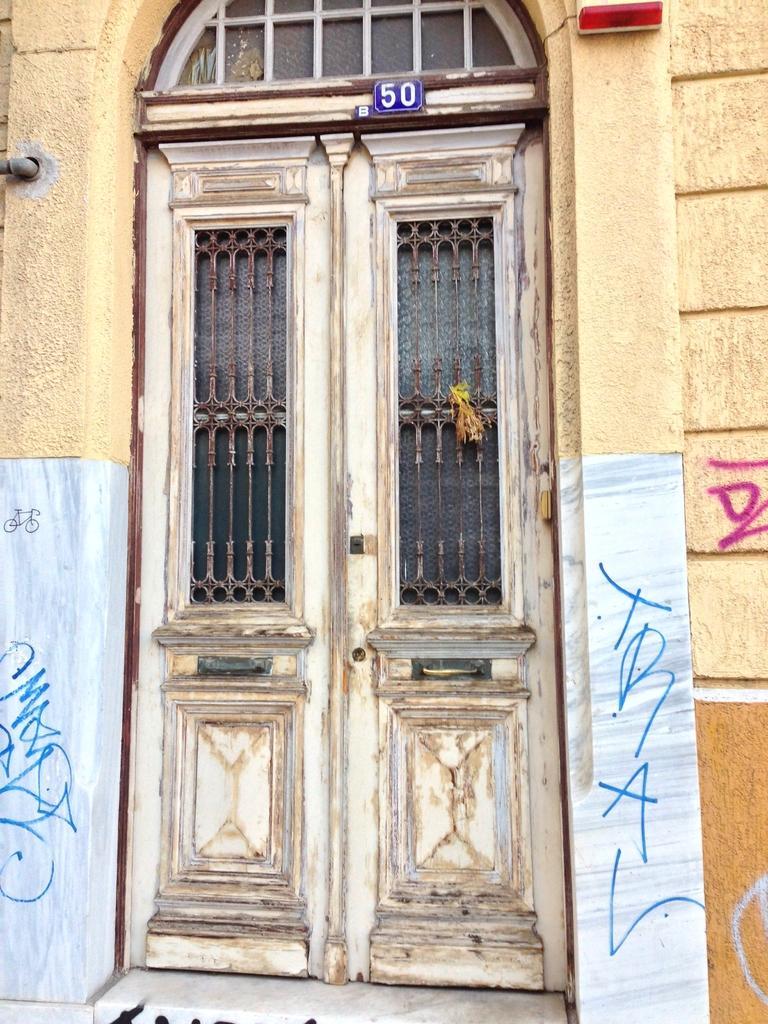Can you describe this image briefly? In this image I can see a building,windows and door. I can see a blue color board attached to the door. 